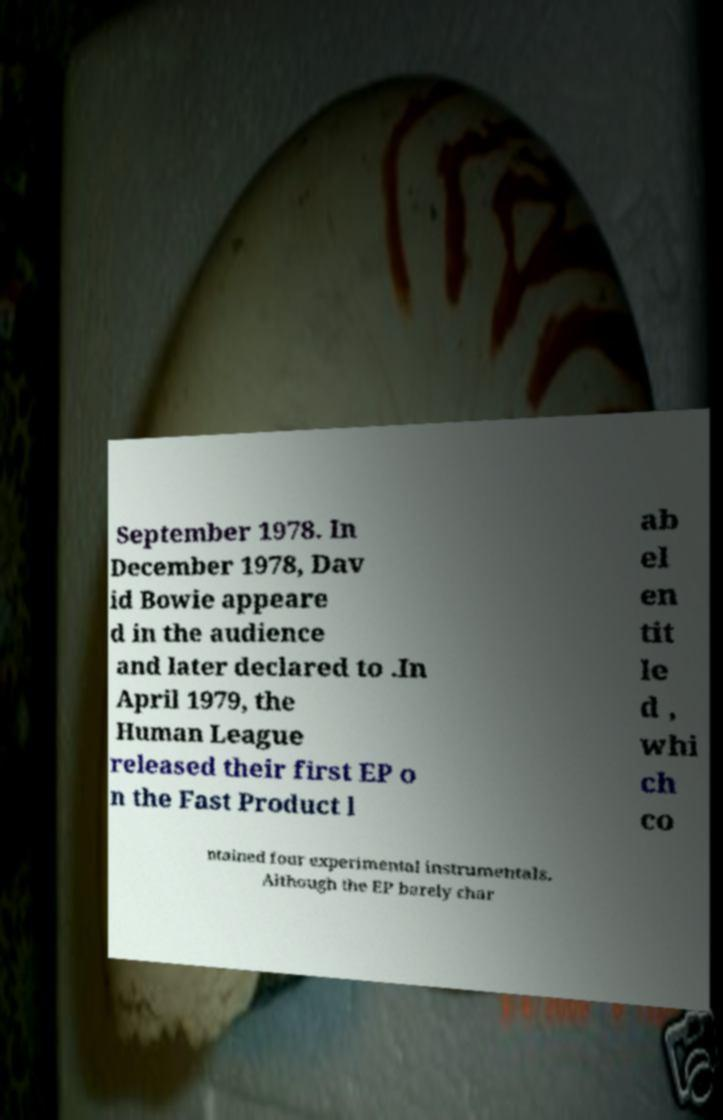I need the written content from this picture converted into text. Can you do that? September 1978. In December 1978, Dav id Bowie appeare d in the audience and later declared to .In April 1979, the Human League released their first EP o n the Fast Product l ab el en tit le d , whi ch co ntained four experimental instrumentals. Although the EP barely char 